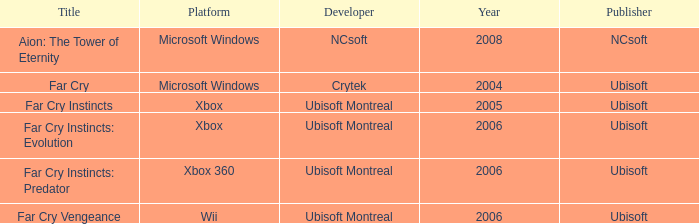Which developer has xbox 360 as the platform? Ubisoft Montreal. 